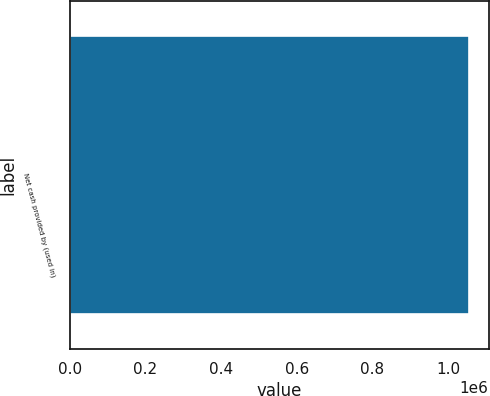Convert chart. <chart><loc_0><loc_0><loc_500><loc_500><bar_chart><fcel>Net cash provided by (used in)<nl><fcel>1.05426e+06<nl></chart> 